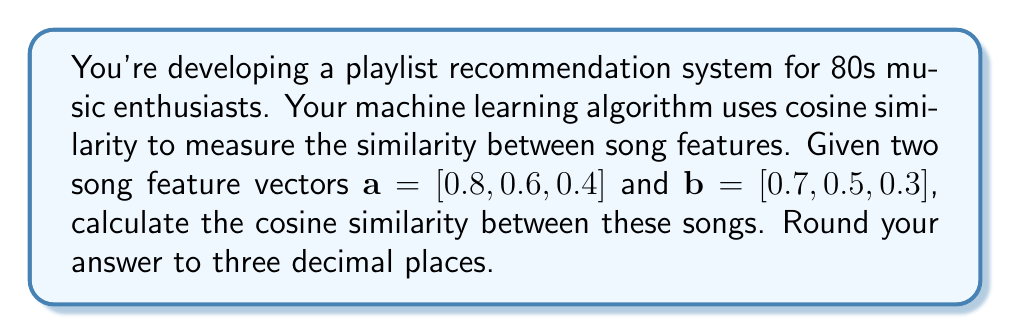Can you answer this question? To solve this problem, we'll use the cosine similarity formula and follow these steps:

1) The cosine similarity between two vectors $\mathbf{a}$ and $\mathbf{b}$ is defined as:

   $$\text{cosine similarity} = \frac{\mathbf{a} \cdot \mathbf{b}}{\|\mathbf{a}\| \|\mathbf{b}\|}$$

   where $\cdot$ represents the dot product and $\|\mathbf{a}\|$ is the magnitude of vector $\mathbf{a}$.

2) Calculate the dot product $\mathbf{a} \cdot \mathbf{b}$:
   $$(0.8 \times 0.7) + (0.6 \times 0.5) + (0.4 \times 0.3) = 0.56 + 0.30 + 0.12 = 0.98$$

3) Calculate $\|\mathbf{a}\|$:
   $$\|\mathbf{a}\| = \sqrt{0.8^2 + 0.6^2 + 0.4^2} = \sqrt{0.64 + 0.36 + 0.16} = \sqrt{1.16} \approx 1.0770$$

4) Calculate $\|\mathbf{b}\|$:
   $$\|\mathbf{b}\| = \sqrt{0.7^2 + 0.5^2 + 0.3^2} = \sqrt{0.49 + 0.25 + 0.09} = \sqrt{0.83} \approx 0.9110$$

5) Now, let's put it all together:

   $$\text{cosine similarity} = \frac{0.98}{1.0770 \times 0.9110} \approx 0.9978$$

6) Rounding to three decimal places, we get 0.998.
Answer: 0.998 